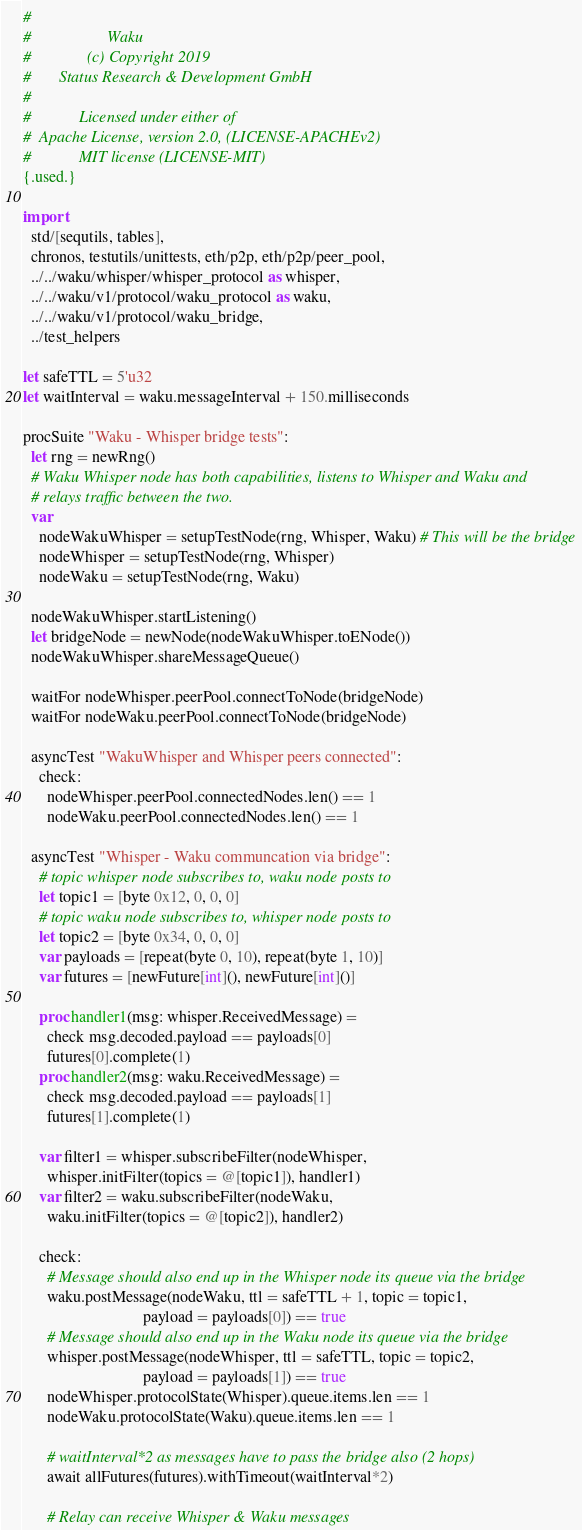<code> <loc_0><loc_0><loc_500><loc_500><_Nim_>#
#                   Waku
#              (c) Copyright 2019
#       Status Research & Development GmbH
#
#            Licensed under either of
#  Apache License, version 2.0, (LICENSE-APACHEv2)
#            MIT license (LICENSE-MIT)
{.used.}

import
  std/[sequtils, tables],
  chronos, testutils/unittests, eth/p2p, eth/p2p/peer_pool,
  ../../waku/whisper/whisper_protocol as whisper,
  ../../waku/v1/protocol/waku_protocol as waku,
  ../../waku/v1/protocol/waku_bridge,
  ../test_helpers

let safeTTL = 5'u32
let waitInterval = waku.messageInterval + 150.milliseconds

procSuite "Waku - Whisper bridge tests":
  let rng = newRng()
  # Waku Whisper node has both capabilities, listens to Whisper and Waku and
  # relays traffic between the two.
  var
    nodeWakuWhisper = setupTestNode(rng, Whisper, Waku) # This will be the bridge
    nodeWhisper = setupTestNode(rng, Whisper)
    nodeWaku = setupTestNode(rng, Waku)

  nodeWakuWhisper.startListening()
  let bridgeNode = newNode(nodeWakuWhisper.toENode())
  nodeWakuWhisper.shareMessageQueue()

  waitFor nodeWhisper.peerPool.connectToNode(bridgeNode)
  waitFor nodeWaku.peerPool.connectToNode(bridgeNode)

  asyncTest "WakuWhisper and Whisper peers connected":
    check:
      nodeWhisper.peerPool.connectedNodes.len() == 1
      nodeWaku.peerPool.connectedNodes.len() == 1

  asyncTest "Whisper - Waku communcation via bridge":
    # topic whisper node subscribes to, waku node posts to
    let topic1 = [byte 0x12, 0, 0, 0]
    # topic waku node subscribes to, whisper node posts to
    let topic2 = [byte 0x34, 0, 0, 0]
    var payloads = [repeat(byte 0, 10), repeat(byte 1, 10)]
    var futures = [newFuture[int](), newFuture[int]()]

    proc handler1(msg: whisper.ReceivedMessage) =
      check msg.decoded.payload == payloads[0]
      futures[0].complete(1)
    proc handler2(msg: waku.ReceivedMessage) =
      check msg.decoded.payload == payloads[1]
      futures[1].complete(1)

    var filter1 = whisper.subscribeFilter(nodeWhisper,
      whisper.initFilter(topics = @[topic1]), handler1)
    var filter2 = waku.subscribeFilter(nodeWaku,
      waku.initFilter(topics = @[topic2]), handler2)

    check:
      # Message should also end up in the Whisper node its queue via the bridge
      waku.postMessage(nodeWaku, ttl = safeTTL + 1, topic = topic1,
                              payload = payloads[0]) == true
      # Message should also end up in the Waku node its queue via the bridge
      whisper.postMessage(nodeWhisper, ttl = safeTTL, topic = topic2,
                              payload = payloads[1]) == true
      nodeWhisper.protocolState(Whisper).queue.items.len == 1
      nodeWaku.protocolState(Waku).queue.items.len == 1

      # waitInterval*2 as messages have to pass the bridge also (2 hops)
      await allFutures(futures).withTimeout(waitInterval*2)

      # Relay can receive Whisper & Waku messages</code> 